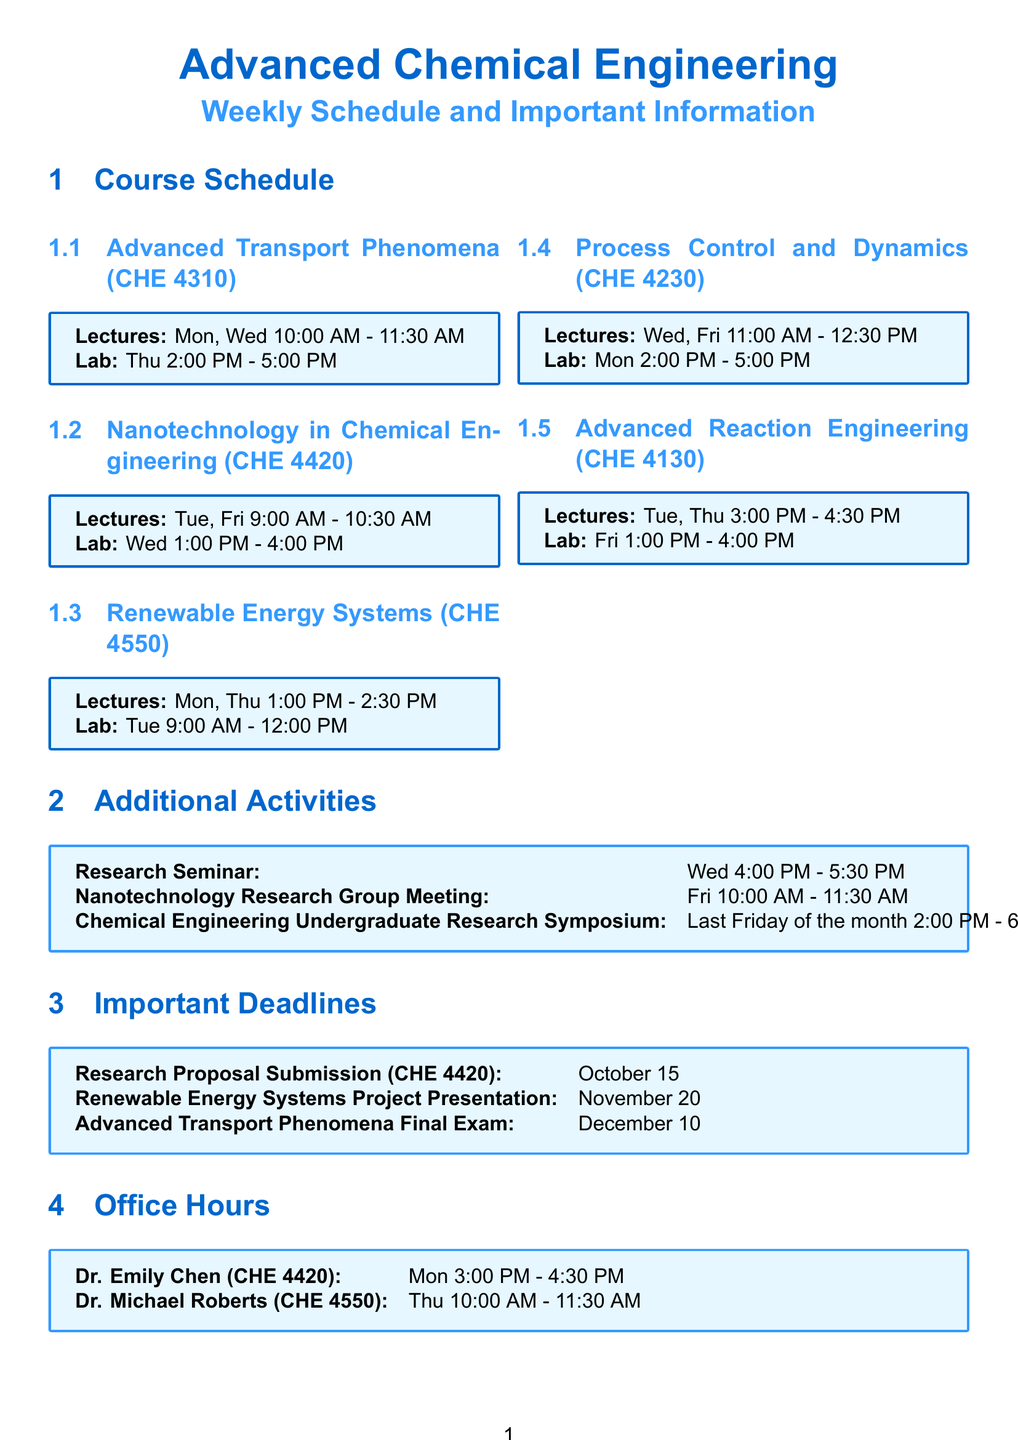What are the lecture days for Advanced Transport Phenomena? The document states that the lecture days are Monday and Wednesday for the course Advanced Transport Phenomena.
Answer: Monday, Wednesday What is the lab time for Nanotechnology in Chemical Engineering? The document specifies that the lab time for Nanotechnology in Chemical Engineering is from 1:00 PM to 4:00 PM on Wednesday.
Answer: 1:00 PM - 4:00 PM When is the Research Proposal Submission due? According to the document, the Research Proposal Submission is due on October 15.
Answer: October 15 Which professor has office hours on Thursday? The document mentions Dr. Michael Roberts having office hours on Thursday for the course Renewable Energy Systems.
Answer: Dr. Michael Roberts What is the duration of the Research Seminar? The document indicates that the Research Seminar lasts for one and a half hours, from 4:00 PM to 5:30 PM.
Answer: One and a half hours How many lab sessions are scheduled on Tuesday? From the document, it is stated there are two courses (Renewable Energy Systems and Advanced Reaction Engineering) with lab sessions scheduled on Tuesday.
Answer: Two On what day is the Chemical Engineering Undergraduate Research Symposium held? The document states that the symposium is held on the last Friday of the month.
Answer: Last Friday of the month What is the lecture time for Process Control and Dynamics? The document specifies that the lecture time for Process Control and Dynamics is from 11:00 AM to 12:30 PM on Wednesday and Friday.
Answer: 11:00 AM - 12:30 PM Which course has its final exam on December 10? The document indicates that the final exam for Advanced Transport Phenomena is scheduled for December 10.
Answer: Advanced Transport Phenomena 